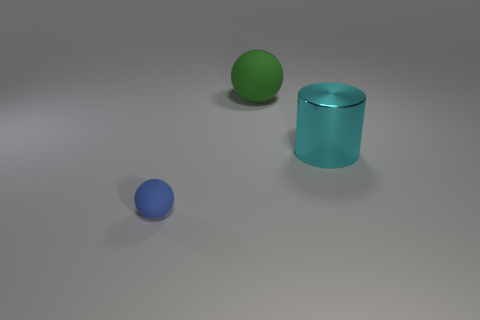The large object that is in front of the big matte object on the right side of the small thing is what color?
Give a very brief answer. Cyan. How many small objects are balls or green balls?
Offer a terse response. 1. The thing that is both in front of the big green thing and on the left side of the big cylinder is what color?
Provide a short and direct response. Blue. Is the material of the tiny sphere the same as the cylinder?
Provide a short and direct response. No. The large cyan metal object is what shape?
Make the answer very short. Cylinder. How many blue matte balls are to the left of the sphere that is behind the big object that is on the right side of the green rubber sphere?
Your response must be concise. 1. The other thing that is the same shape as the tiny rubber object is what color?
Your answer should be very brief. Green. The matte object that is to the right of the thing left of the ball that is behind the tiny blue rubber object is what shape?
Your answer should be compact. Sphere. How big is the object that is to the left of the cyan thing and in front of the large green object?
Make the answer very short. Small. Is the number of blue rubber spheres less than the number of blue matte blocks?
Offer a terse response. No. 